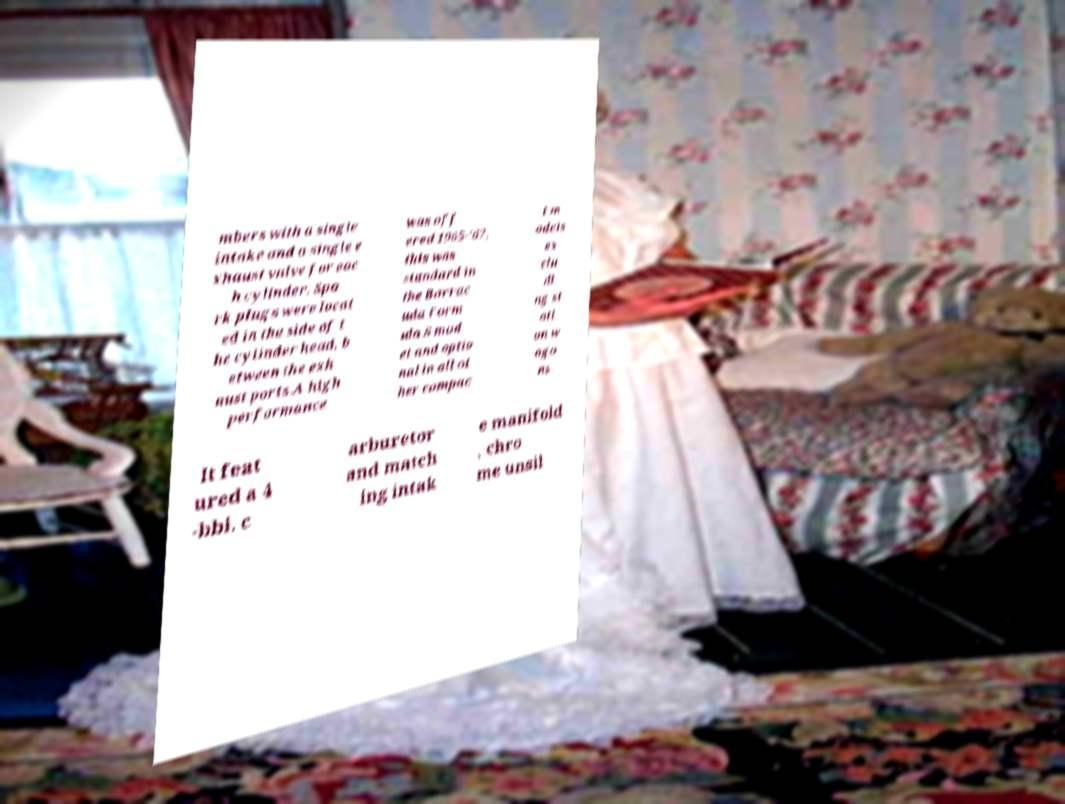Please read and relay the text visible in this image. What does it say? mbers with a single intake and a single e xhaust valve for eac h cylinder. Spa rk plugs were locat ed in the side of t he cylinder head, b etween the exh aust ports.A high performance was off ered 1965-'67, this was standard in the Barrac uda Form ula S mod el and optio nal in all ot her compac t m odels ex clu di ng st ati on w ago ns. It feat ured a 4 -bbl. c arburetor and match ing intak e manifold , chro me unsil 